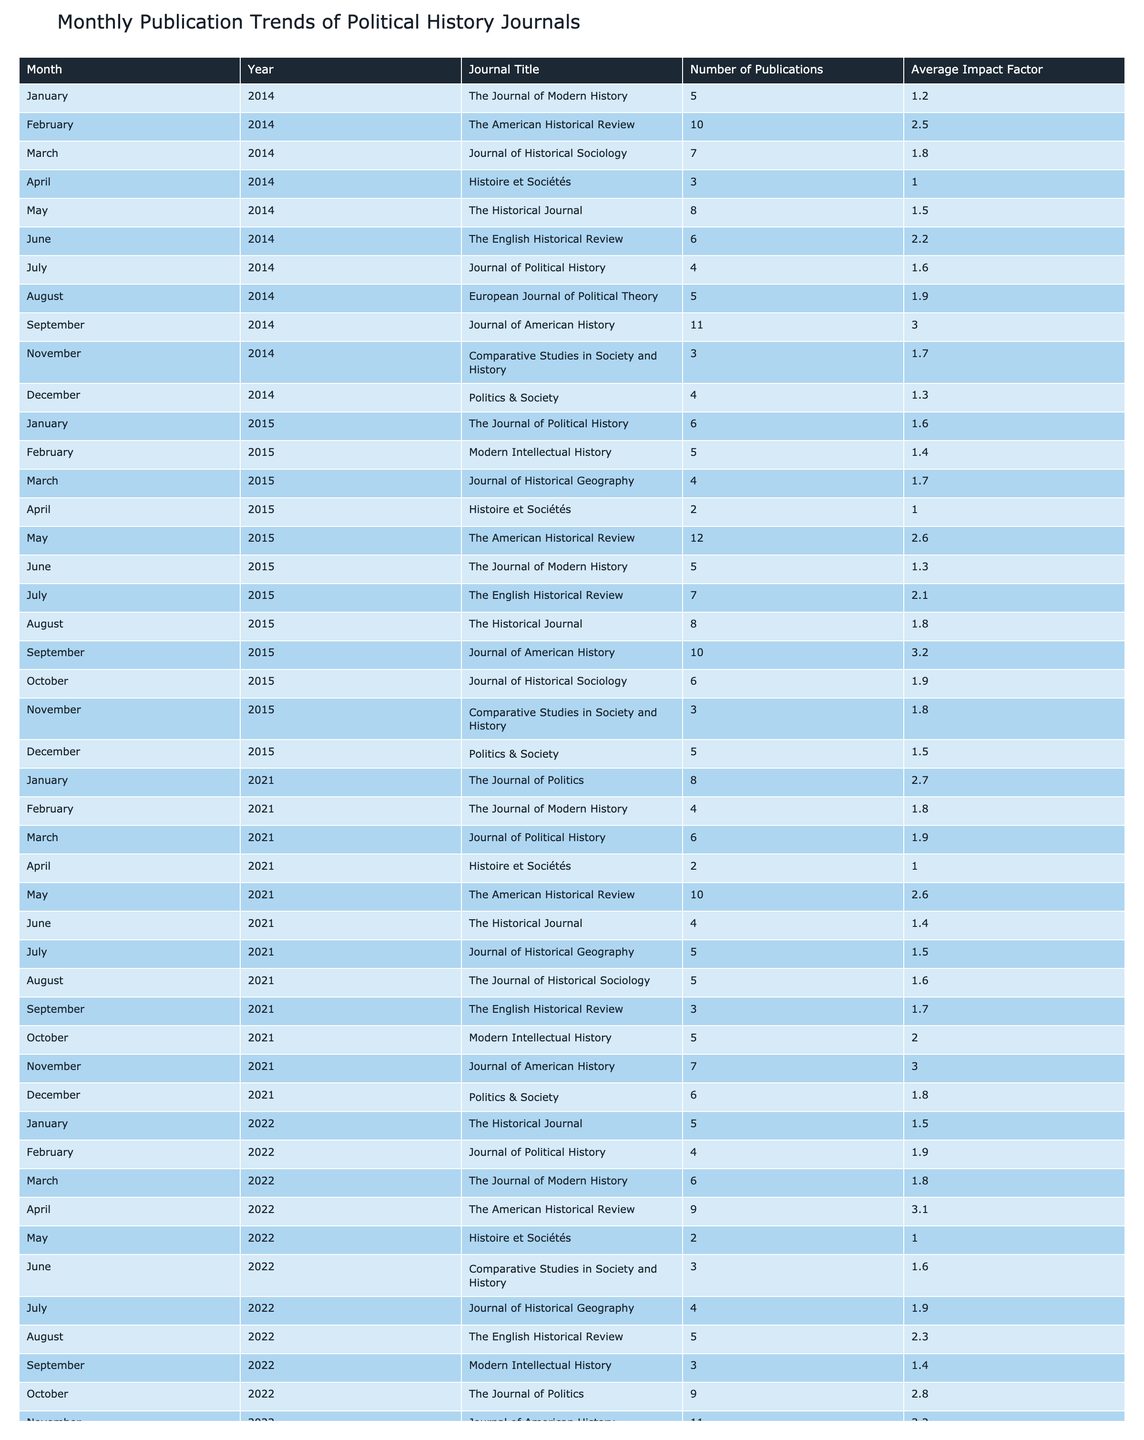What is the total number of publications in September across all years provided? To find the total number of publications in September, we sum the values of the "Number of Publications" column for September in each year: 11 (2014) + 10 (2015) + 7 (2021) + 3 (2022) = 31.
Answer: 31 Which journal has the highest average impact factor in the table? To determine the journal with the highest average impact factor, we must compare the "Average Impact Factor" values: The Journal of American History (3.2 in 2015 and 2022) has the highest average impact factor, as no other journal reaches that value.
Answer: The Journal of American History In which month and year was the lowest number of publications recorded? By examining the "Number of Publications" column, the lowest value is 2, recorded in April 2015 and May 2021 for Histoire et Sociétés.
Answer: April 2015 and May 2021 What is the average number of publications per year for the Journal of Political History? The Journal of Political History has the following publications listed: 4 (2014), 6 (2015), 6 (2021), 4 (2022). Therefore, sum those values: 4 + 6 + 6 + 4 = 20. There are four entries, so the average is 20 / 4 = 5.
Answer: 5 Is there a year where Politics & Society had more than five publications? By checking the "Number of Publications" column for Politics & Society, we find the values: 4 (2014), 5 (2015), 6 (2021), 7 (2022). Since one value (7) is greater than five, the answer is yes.
Answer: Yes What is the difference in publications between the months of April in 2021 and 2014? We find the number of publications for April 2021 (2) and April 2014 (3) in the table. The difference is calculated as 3 - 2 = 1.
Answer: 1 How many journals have an average impact factor above 2.0? We filter the "Average Impact Factor" column for values greater than 2.0. The journals with such ratings are: The American Historical Review (2.5 in 2014 and 2.6 in 2015), Journal of American History (3.0 in 2014 and 3.2 in 2015 and 2022), and The Journal of Politics (2.7 in 2021 and 2.8 in 2022). There are 5 entries in total.
Answer: 5 What is the total average impact factor of publications in December across all years? We take the average impact factor for December from the table: 1.3 (2014), 1.5 (2015), 1.8 (2021), and 1.7 (2022). Adding these gives us 1.3 + 1.5 + 1.8 + 1.7 = 6.3. There are four entries, so the average factor is 6.3 / 4 = 1.575, which rounds to approximately 1.6.
Answer: 1.6 